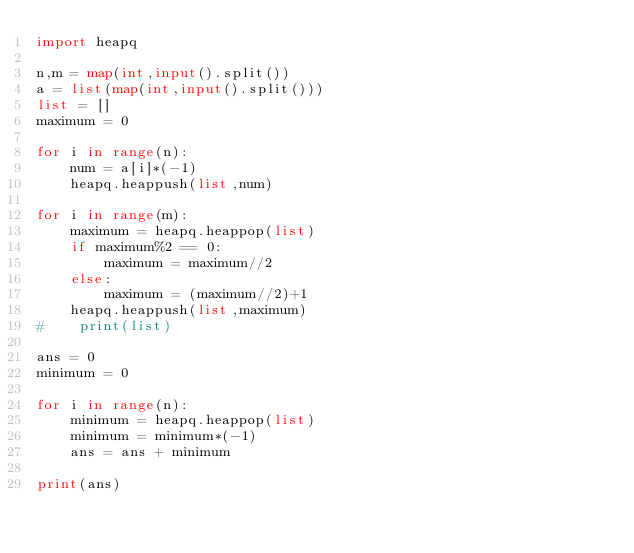Convert code to text. <code><loc_0><loc_0><loc_500><loc_500><_Python_>import heapq

n,m = map(int,input().split())
a = list(map(int,input().split()))
list = []
maximum = 0

for i in range(n):
    num = a[i]*(-1)
    heapq.heappush(list,num)

for i in range(m):
    maximum = heapq.heappop(list)
    if maximum%2 == 0:
        maximum = maximum//2
    else:
        maximum = (maximum//2)+1
    heapq.heappush(list,maximum)
#    print(list)

ans = 0
minimum = 0

for i in range(n):
    minimum = heapq.heappop(list)
    minimum = minimum*(-1)
    ans = ans + minimum

print(ans)
</code> 